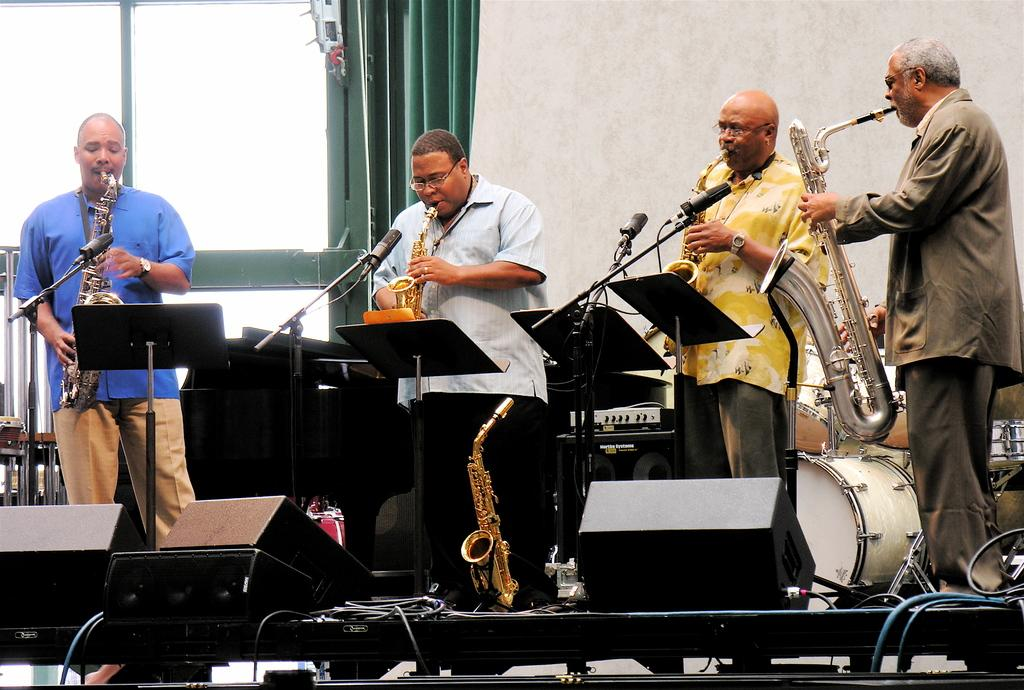What are the men in the image doing? The men in the image are playing trumpets. Where are the men located in the image? They are in front of a microphone and on a stage. What other instruments can be seen in the image? There are drums behind the men. What is present on the left side of the image? There is a window with a curtain on the left side of the image. How much payment do the men receive for their performance in the image? There is no information about payment in the image, as it only shows the men playing trumpets and the surrounding elements. 